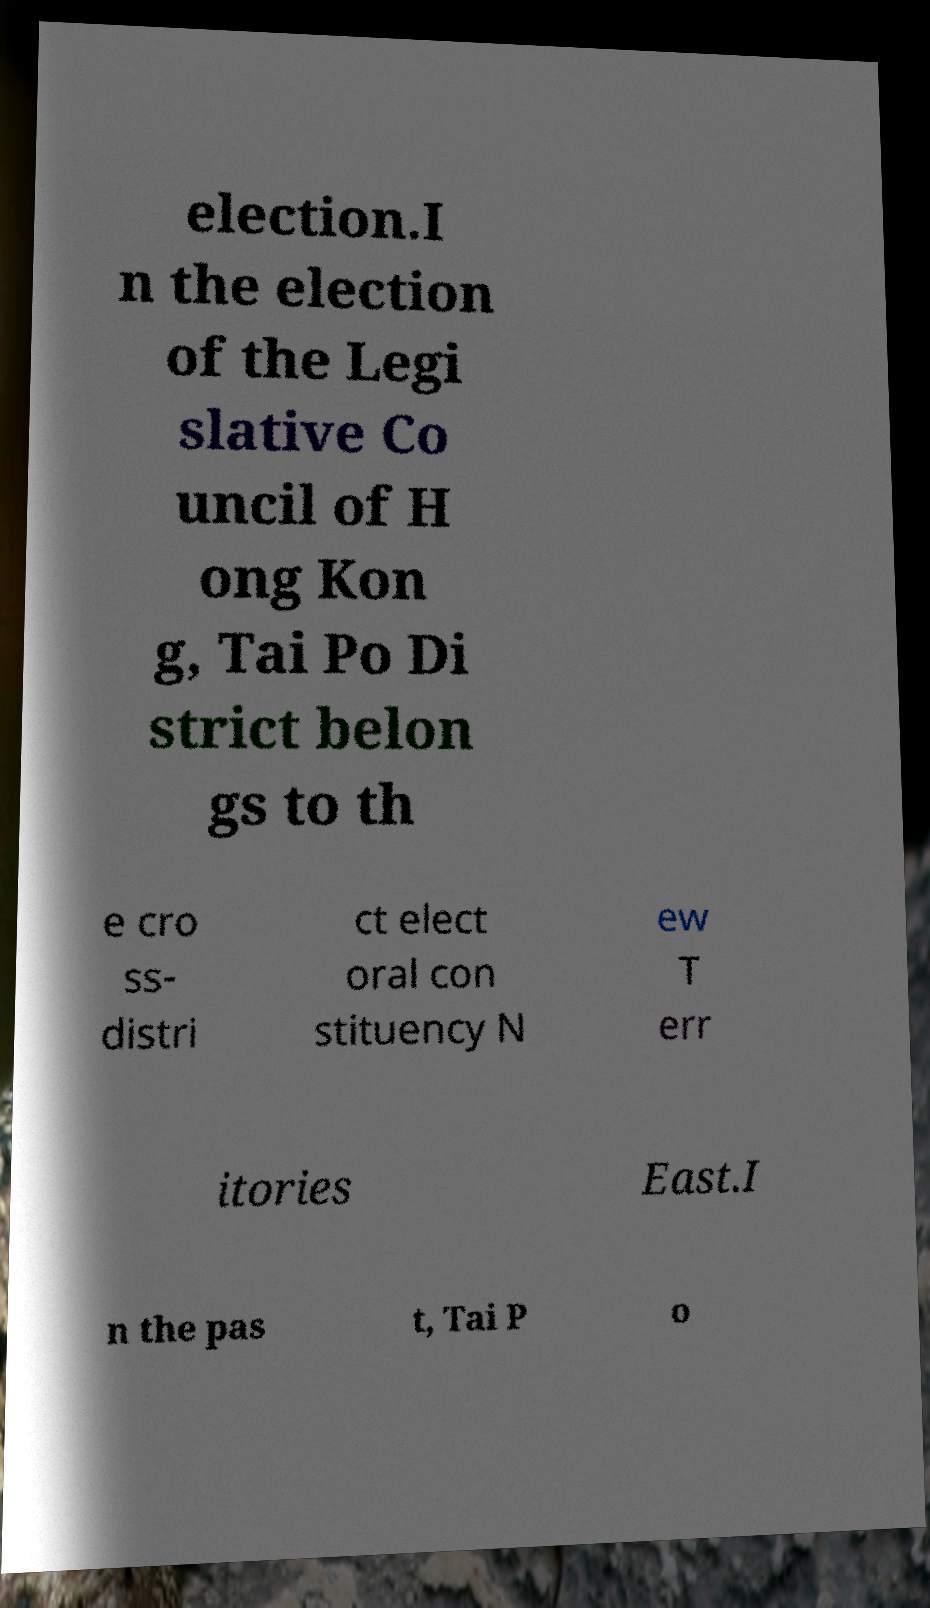There's text embedded in this image that I need extracted. Can you transcribe it verbatim? election.I n the election of the Legi slative Co uncil of H ong Kon g, Tai Po Di strict belon gs to th e cro ss- distri ct elect oral con stituency N ew T err itories East.I n the pas t, Tai P o 